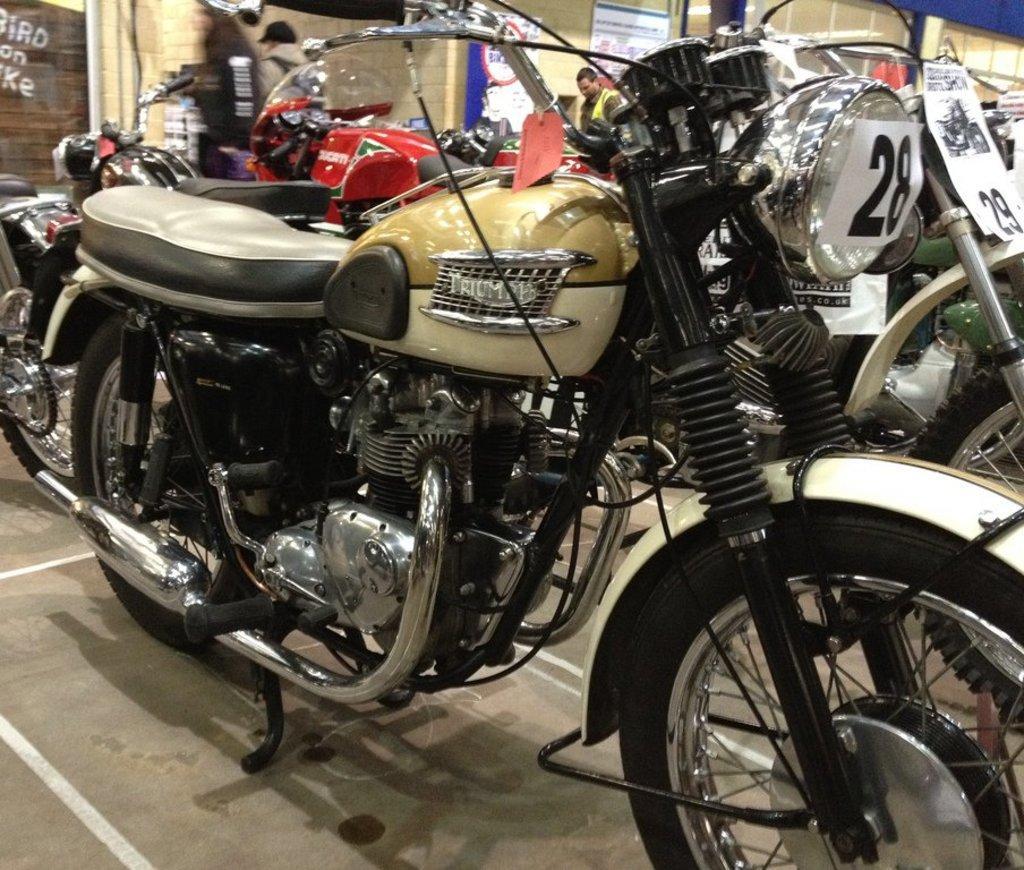In one or two sentences, can you explain what this image depicts? In the picture there are many vehicles kept one beside another and behind the vehicles there is a wall and few posters were stick to the wall, there are two people in front of the wall. 